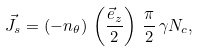<formula> <loc_0><loc_0><loc_500><loc_500>\vec { J } _ { s } = ( - n _ { \theta } ) \, \left ( \frac { \vec { e } _ { z } } { 2 } \right ) \, \frac { \pi } { 2 } \, \gamma N _ { c } ,</formula> 